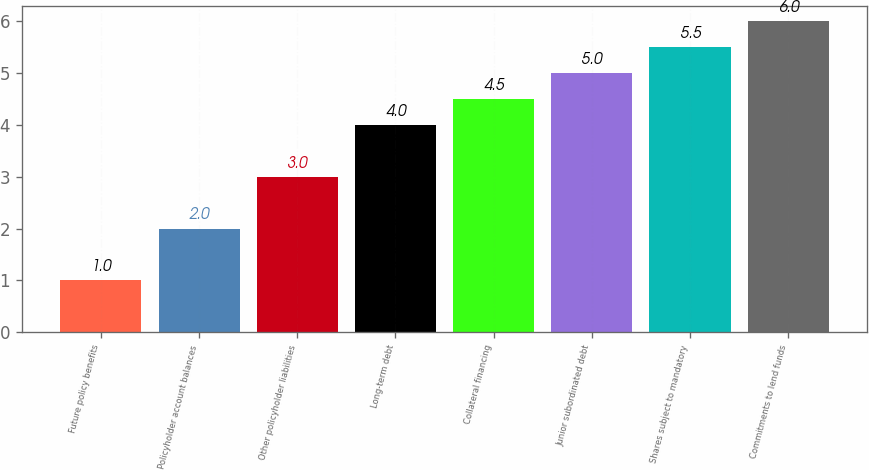Convert chart. <chart><loc_0><loc_0><loc_500><loc_500><bar_chart><fcel>Future policy benefits<fcel>Policyholder account balances<fcel>Other policyholder liabilities<fcel>Long-term debt<fcel>Collateral financing<fcel>Junior subordinated debt<fcel>Shares subject to mandatory<fcel>Commitments to lend funds<nl><fcel>1<fcel>2<fcel>3<fcel>4<fcel>4.5<fcel>5<fcel>5.5<fcel>6<nl></chart> 